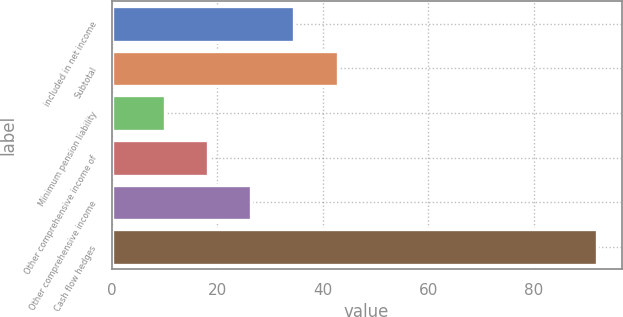Convert chart. <chart><loc_0><loc_0><loc_500><loc_500><bar_chart><fcel>included in net income<fcel>Subtotal<fcel>Minimum pension liability<fcel>Other comprehensive income of<fcel>Other comprehensive income<fcel>Cash flow hedges<nl><fcel>34.6<fcel>42.8<fcel>10<fcel>18.2<fcel>26.4<fcel>92<nl></chart> 